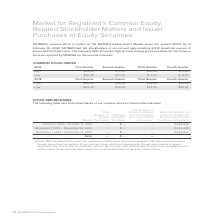According to Adtran's financial document, What symbol is ADTRAN's common stock traded under on the NASDAQ Global Select Market? According to the financial document, ADTN.. The relevant text states: "n the NASDAQ Global Select Market under the symbol ADTN. As of February 19, 2020, ADTRAN had 163 stockholders of record and approximately 6,972 beneficial ow..." Also, What was the high closing price for common stock price in the First Quarter of 2019? According to the financial document, $15.40. The relevant text states: "High $15.40 $ 17.81 $16.40 $11.59..." Also, What was the high closing price for common stock price in the Fourth Quarter of 2019? According to the financial document, $11.59. The relevant text states: "High $15.40 $ 17.81 $16.40 $11.59..." Also, can you calculate: What was the difference between the high and low closing prices per share for common stock in the second quarter of 2019? Based on the calculation: $17.81-$13.76, the result is 4.05. This is based on the information: "Low $10.49 $13.76 $ 9.92 $ 8.09 High $15.40 $ 17.81 $16.40 $11.59..." The key data points involved are: 13.76, 17.81. Also, can you calculate: What was the average low closing price for 2019? To answer this question, I need to perform calculations using the financial data. The calculation is: ( $10.49 + $13.76 + $ 9.92 + $ 8.09 )/4, which equals 10.57. This is based on the information: "Low $10.49 $13.76 $ 9.92 $ 8.09 Low $10.49 $13.76 $ 9.92 $ 8.09 Low $10.49 $13.76 $ 9.92 $ 8.09 Low $10.49 $13.76 $ 9.92 $ 8.09..." The key data points involved are: 10.49, 13.76, 8.09. Also, can you calculate: What was the percentage change in the high closing price between the third and fourth quarter in 2019? To answer this question, I need to perform calculations using the financial data. The calculation is: ($11.59-$16.40)/$16.40, which equals -29.33 (percentage). This is based on the information: "High $15.40 $ 17.81 $16.40 $11.59 High $15.40 $ 17.81 $16.40 $11.59..." The key data points involved are: 11.59, 16.40. 